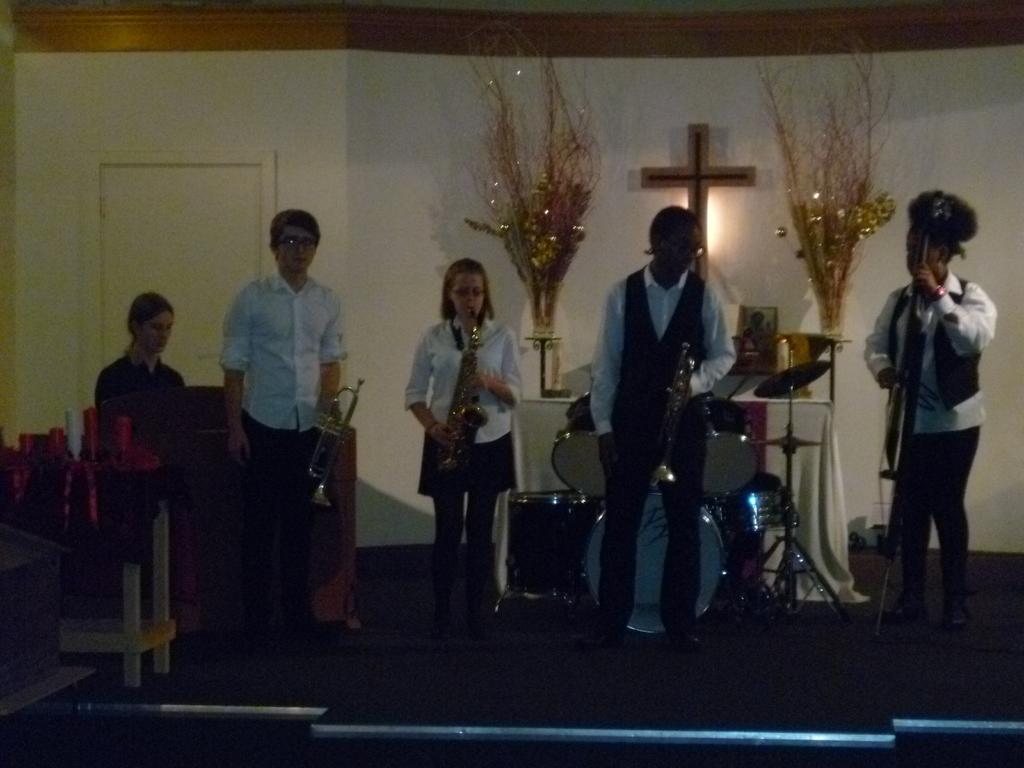In one or two sentences, can you explain what this image depicts? In this picture we can see a group of people,here we can see musical instruments and in the background we can see a wall. 